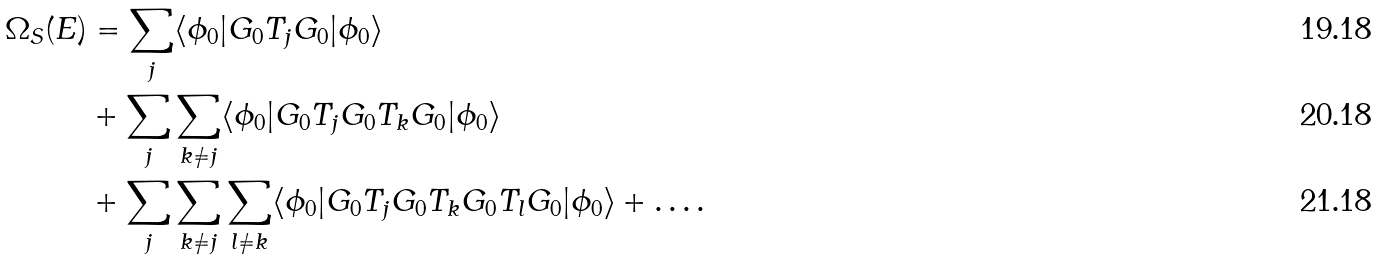<formula> <loc_0><loc_0><loc_500><loc_500>\Omega _ { S } ( E ) & = \sum _ { j } \langle \phi _ { 0 } | G _ { 0 } T _ { j } G _ { 0 } | \phi _ { 0 } \rangle \\ & + \sum _ { j } \sum _ { k \neq j } \langle \phi _ { 0 } | G _ { 0 } T _ { j } G _ { 0 } T _ { k } G _ { 0 } | \phi _ { 0 } \rangle \\ & + \sum _ { j } \sum _ { k \neq j } \sum _ { l \neq k } \langle \phi _ { 0 } | G _ { 0 } T _ { j } G _ { 0 } T _ { k } G _ { 0 } T _ { l } G _ { 0 } | \phi _ { 0 } \rangle + \dots .</formula> 